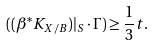Convert formula to latex. <formula><loc_0><loc_0><loc_500><loc_500>( ( \beta ^ { * } K _ { X / B } ) | _ { S } \cdot \Gamma ) \geq \frac { 1 } { 3 } t .</formula> 